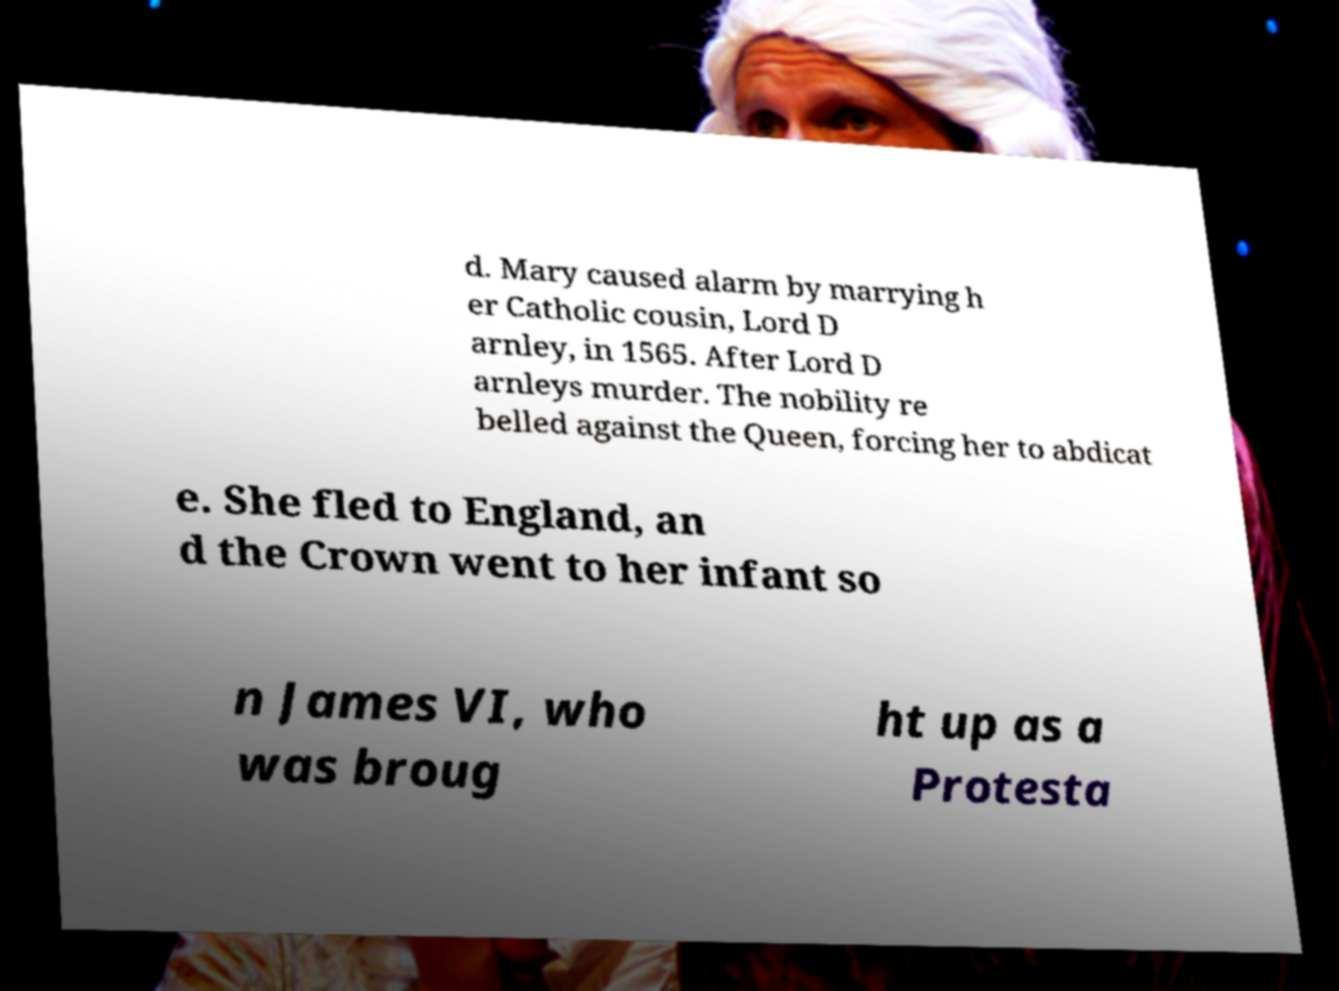Could you extract and type out the text from this image? d. Mary caused alarm by marrying h er Catholic cousin, Lord D arnley, in 1565. After Lord D arnleys murder. The nobility re belled against the Queen, forcing her to abdicat e. She fled to England, an d the Crown went to her infant so n James VI, who was broug ht up as a Protesta 